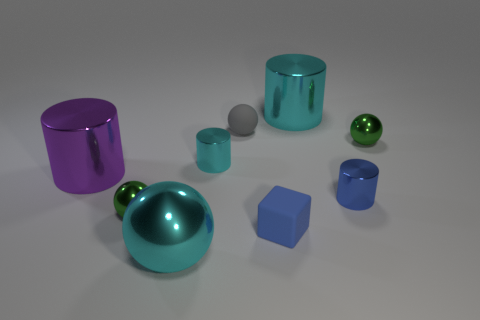The green object in front of the small ball right of the blue metal cylinder is what shape?
Your answer should be very brief. Sphere. Is there a large object?
Offer a terse response. Yes. There is a rubber object in front of the small blue shiny object; what is its color?
Offer a very short reply. Blue. What material is the small cylinder that is the same color as the big sphere?
Offer a terse response. Metal. Are there any small blue matte objects right of the tiny blue metallic cylinder?
Ensure brevity in your answer.  No. Is the number of tiny red things greater than the number of tiny cyan objects?
Provide a succinct answer. No. The tiny metal sphere on the right side of the green shiny ball in front of the small green metallic thing behind the big purple thing is what color?
Provide a short and direct response. Green. There is a sphere that is made of the same material as the tiny blue cube; what is its color?
Give a very brief answer. Gray. Are there any other things that are the same size as the purple shiny thing?
Your answer should be compact. Yes. How many objects are big shiny cylinders that are on the right side of the rubber cube or green shiny objects on the left side of the tiny gray rubber sphere?
Your response must be concise. 2. 